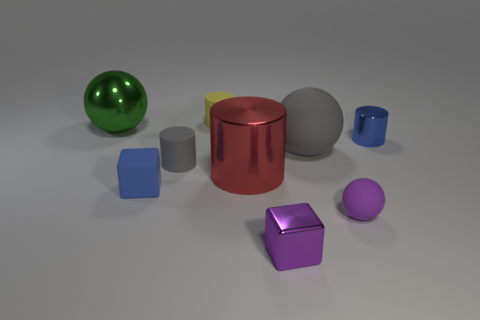Add 1 tiny cyan shiny cylinders. How many objects exist? 10 Subtract all gray cylinders. How many cylinders are left? 3 Subtract all purple cylinders. Subtract all cyan blocks. How many cylinders are left? 4 Subtract all cylinders. How many objects are left? 5 Subtract 1 green spheres. How many objects are left? 8 Subtract all small blue matte things. Subtract all large green metal balls. How many objects are left? 7 Add 8 tiny gray cylinders. How many tiny gray cylinders are left? 9 Add 6 large brown metal objects. How many large brown metal objects exist? 6 